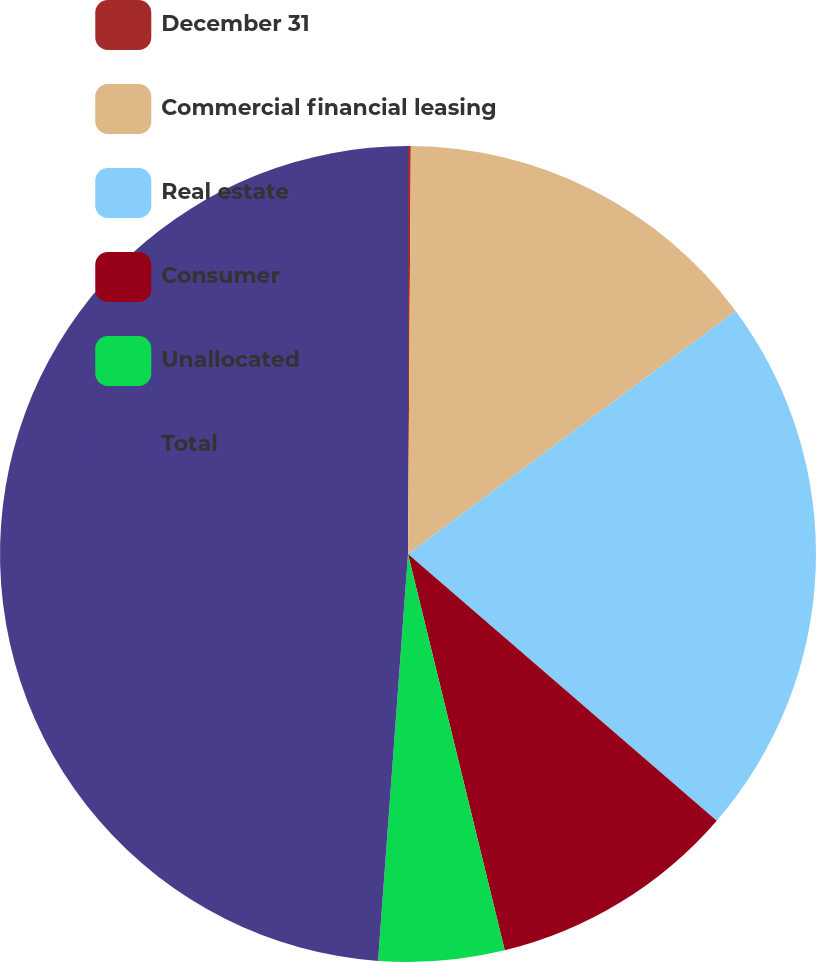Convert chart. <chart><loc_0><loc_0><loc_500><loc_500><pie_chart><fcel>December 31<fcel>Commercial financial leasing<fcel>Real estate<fcel>Consumer<fcel>Unallocated<fcel>Total<nl><fcel>0.11%<fcel>14.73%<fcel>21.5%<fcel>9.85%<fcel>4.98%<fcel>48.83%<nl></chart> 